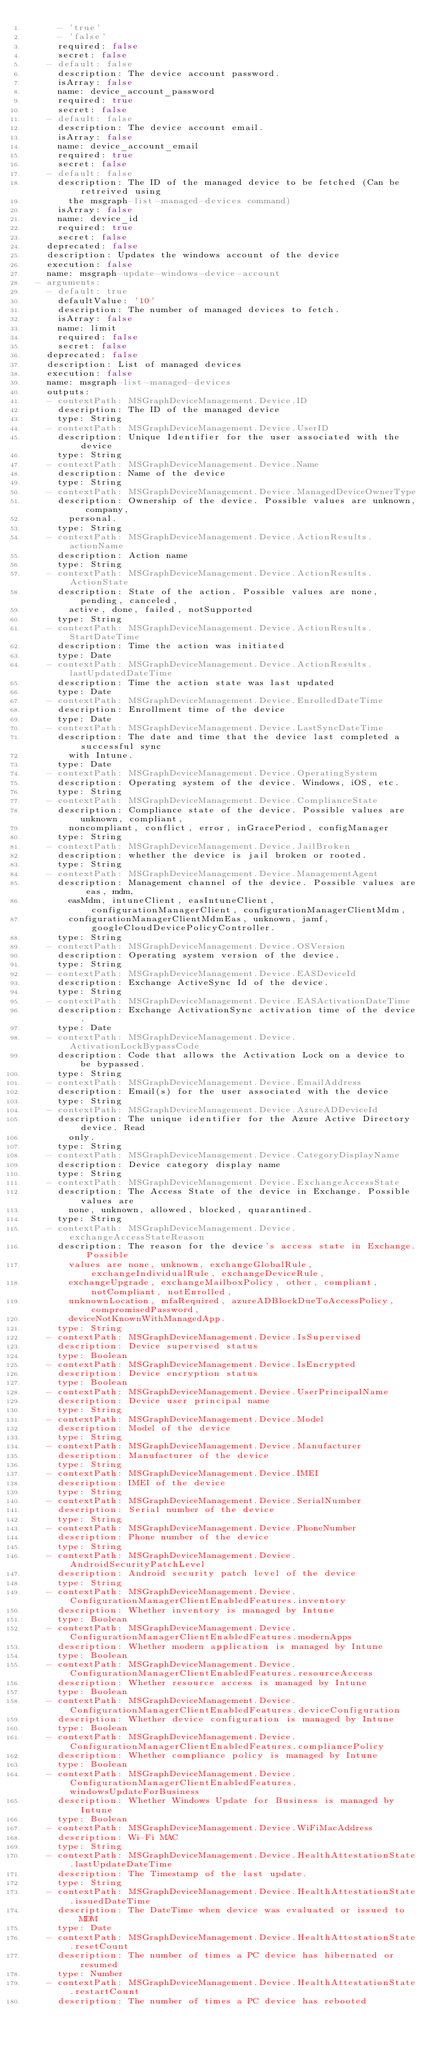<code> <loc_0><loc_0><loc_500><loc_500><_YAML_>      - 'true'
      - 'false'
      required: false
      secret: false
    - default: false
      description: The device account password.
      isArray: false
      name: device_account_password
      required: true
      secret: false
    - default: false
      description: The device account email.
      isArray: false
      name: device_account_email
      required: true
      secret: false
    - default: false
      description: The ID of the managed device to be fetched (Can be retreived using
        the msgraph-list-managed-devices command)
      isArray: false
      name: device_id
      required: true
      secret: false
    deprecated: false
    description: Updates the windows account of the device
    execution: false
    name: msgraph-update-windows-device-account
  - arguments:
    - default: true
      defaultValue: '10'
      description: The number of managed devices to fetch.
      isArray: false
      name: limit
      required: false
      secret: false
    deprecated: false
    description: List of managed devices
    execution: false
    name: msgraph-list-managed-devices
    outputs:
    - contextPath: MSGraphDeviceManagement.Device.ID
      description: The ID of the managed device
      type: String
    - contextPath: MSGraphDeviceManagement.Device.UserID
      description: Unique Identifier for the user associated with the device
      type: String
    - contextPath: MSGraphDeviceManagement.Device.Name
      description: Name of the device
      type: String
    - contextPath: MSGraphDeviceManagement.Device.ManagedDeviceOwnerType
      description: Ownership of the device. Possible values are unknown, company,
        personal.
      type: String
    - contextPath: MSGraphDeviceManagement.Device.ActionResults.actionName
      description: Action name
      type: String
    - contextPath: MSGraphDeviceManagement.Device.ActionResults.ActionState
      description: State of the action. Possible values are none, pending, canceled,
        active, done, failed, notSupported
      type: String
    - contextPath: MSGraphDeviceManagement.Device.ActionResults.StartDateTime
      description: Time the action was initiated
      type: Date
    - contextPath: MSGraphDeviceManagement.Device.ActionResults.lastUpdatedDateTime
      description: Time the action state was last updated
      type: Date
    - contextPath: MSGraphDeviceManagement.Device.EnrolledDateTime
      description: Enrollment time of the device
      type: Date
    - contextPath: MSGraphDeviceManagement.Device.LastSyncDateTime
      description: The date and time that the device last completed a successful sync
        with Intune.
      type: Date
    - contextPath: MSGraphDeviceManagement.Device.OperatingSystem
      description: Operating system of the device. Windows, iOS, etc.
      type: String
    - contextPath: MSGraphDeviceManagement.Device.ComplianceState
      description: Compliance state of the device. Possible values are unknown, compliant,
        noncompliant, conflict, error, inGracePeriod, configManager
      type: String
    - contextPath: MSGraphDeviceManagement.Device.JailBroken
      description: whether the device is jail broken or rooted.
      type: String
    - contextPath: MSGraphDeviceManagement.Device.ManagementAgent
      description: Management channel of the device. Possible values are eas, mdm,
        easMdm, intuneClient, easIntuneClient, configurationManagerClient, configurationManagerClientMdm,
        configurationManagerClientMdmEas, unknown, jamf, googleCloudDevicePolicyController.
      type: String
    - contextPath: MSGraphDeviceManagement.Device.OSVersion
      description: Operating system version of the device.
      type: String
    - contextPath: MSGraphDeviceManagement.Device.EASDeviceId
      description: Exchange ActiveSync Id of the device.
      type: String
    - contextPath: MSGraphDeviceManagement.Device.EASActivationDateTime
      description: Exchange ActivationSync activation time of the device.
      type: Date
    - contextPath: MSGraphDeviceManagement.Device.ActivationLockBypassCode
      description: Code that allows the Activation Lock on a device to be bypassed.
      type: String
    - contextPath: MSGraphDeviceManagement.Device.EmailAddress
      description: Email(s) for the user associated with the device
      type: String
    - contextPath: MSGraphDeviceManagement.Device.AzureADDeviceId
      description: The unique identifier for the Azure Active Directory device. Read
        only.
      type: String
    - contextPath: MSGraphDeviceManagement.Device.CategoryDisplayName
      description: Device category display name
      type: String
    - contextPath: MSGraphDeviceManagement.Device.ExchangeAccessState
      description: The Access State of the device in Exchange. Possible values are
        none, unknown, allowed, blocked, quarantined.
      type: String
    - contextPath: MSGraphDeviceManagement.Device.exchangeAccessStateReason
      description: The reason for the device's access state in Exchange. Possible
        values are none, unknown, exchangeGlobalRule, exchangeIndividualRule, exchangeDeviceRule,
        exchangeUpgrade, exchangeMailboxPolicy, other, compliant, notCompliant, notEnrolled,
        unknownLocation, mfaRequired, azureADBlockDueToAccessPolicy, compromisedPassword,
        deviceNotKnownWithManagedApp.
      type: String
    - contextPath: MSGraphDeviceManagement.Device.IsSupervised
      description: Device supervised status
      type: Boolean
    - contextPath: MSGraphDeviceManagement.Device.IsEncrypted
      description: Device encryption status
      type: Boolean
    - contextPath: MSGraphDeviceManagement.Device.UserPrincipalName
      description: Device user principal name
      type: String
    - contextPath: MSGraphDeviceManagement.Device.Model
      description: Model of the device
      type: String
    - contextPath: MSGraphDeviceManagement.Device.Manufacturer
      description: Manufacturer of the device
      type: String
    - contextPath: MSGraphDeviceManagement.Device.IMEI
      description: IMEI of the device
      type: String
    - contextPath: MSGraphDeviceManagement.Device.SerialNumber
      description: Serial number of the device
      type: String
    - contextPath: MSGraphDeviceManagement.Device.PhoneNumber
      description: Phone number of the device
      type: String
    - contextPath: MSGraphDeviceManagement.Device.AndroidSecurityPatchLevel
      description: Android security patch level of the device
      type: String
    - contextPath: MSGraphDeviceManagement.Device.ConfigurationManagerClientEnabledFeatures.inventory
      description: Whether inventory is managed by Intune
      type: Boolean
    - contextPath: MSGraphDeviceManagement.Device.ConfigurationManagerClientEnabledFeatures.modernApps
      description: Whether modern application is managed by Intune
      type: Boolean
    - contextPath: MSGraphDeviceManagement.Device.ConfigurationManagerClientEnabledFeatures.resourceAccess
      description: Whether resource access is managed by Intune
      type: Boolean
    - contextPath: MSGraphDeviceManagement.Device.ConfigurationManagerClientEnabledFeatures.deviceConfiguration
      description: Whether device configuration is managed by Intune
      type: Boolean
    - contextPath: MSGraphDeviceManagement.Device.ConfigurationManagerClientEnabledFeatures.compliancePolicy
      description: Whether compliance policy is managed by Intune
      type: Boolean
    - contextPath: MSGraphDeviceManagement.Device.ConfigurationManagerClientEnabledFeatures.windowsUpdateForBusiness
      description: Whether Windows Update for Business is managed by Intune
      type: Boolean
    - contextPath: MSGraphDeviceManagement.Device.WiFiMacAddress
      description: Wi-Fi MAC
      type: String
    - contextPath: MSGraphDeviceManagement.Device.HealthAttestationState.lastUpdateDateTime
      description: The Timestamp of the last update.
      type: String
    - contextPath: MSGraphDeviceManagement.Device.HealthAttestationState.issuedDateTime
      description: The DateTime when device was evaluated or issued to MDM
      type: Date
    - contextPath: MSGraphDeviceManagement.Device.HealthAttestationState.resetCount
      description: The number of times a PC device has hibernated or resumed
      type: Number
    - contextPath: MSGraphDeviceManagement.Device.HealthAttestationState.restartCount
      description: The number of times a PC device has rebooted</code> 